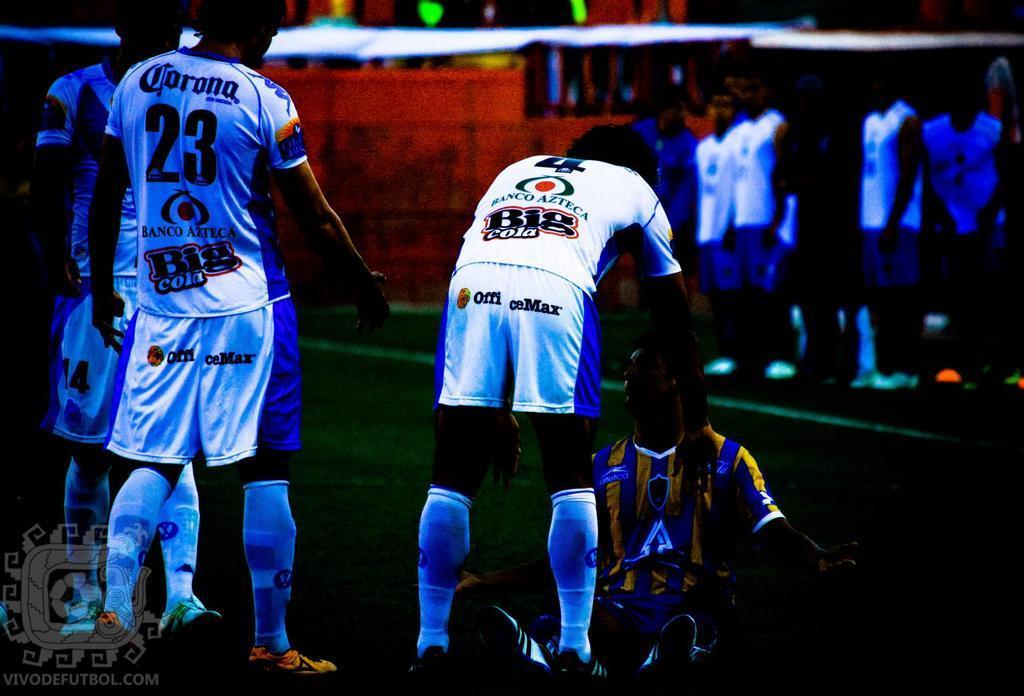Please provide a concise description of this image. This is a edited image. In the foreground of the picture there are men. In the center there is a person sitting on the ground. The background is blurred. In the background there are people. At the bottom left there is a logo. 